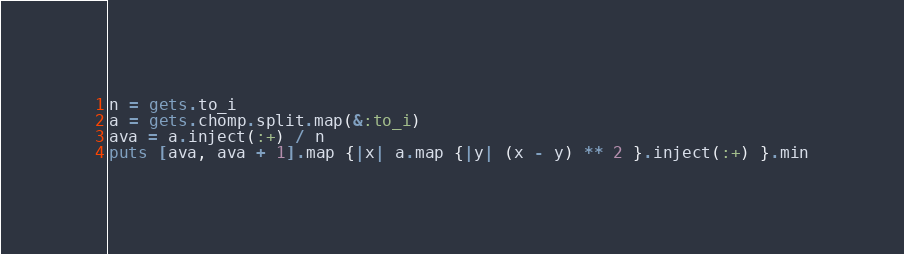Convert code to text. <code><loc_0><loc_0><loc_500><loc_500><_Ruby_>n = gets.to_i
a = gets.chomp.split.map(&:to_i)
ava = a.inject(:+) / n
puts [ava, ava + 1].map {|x| a.map {|y| (x - y) ** 2 }.inject(:+) }.min</code> 